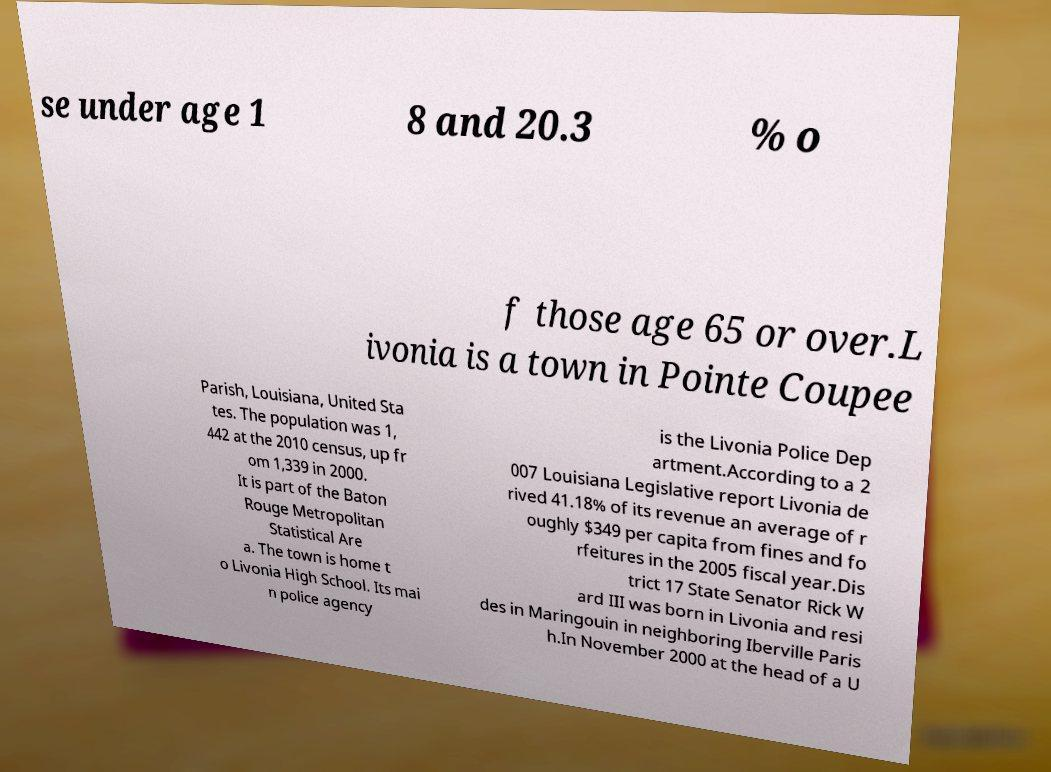Could you assist in decoding the text presented in this image and type it out clearly? se under age 1 8 and 20.3 % o f those age 65 or over.L ivonia is a town in Pointe Coupee Parish, Louisiana, United Sta tes. The population was 1, 442 at the 2010 census, up fr om 1,339 in 2000. It is part of the Baton Rouge Metropolitan Statistical Are a. The town is home t o Livonia High School. Its mai n police agency is the Livonia Police Dep artment.According to a 2 007 Louisiana Legislative report Livonia de rived 41.18% of its revenue an average of r oughly $349 per capita from fines and fo rfeitures in the 2005 fiscal year.Dis trict 17 State Senator Rick W ard III was born in Livonia and resi des in Maringouin in neighboring Iberville Paris h.In November 2000 at the head of a U 